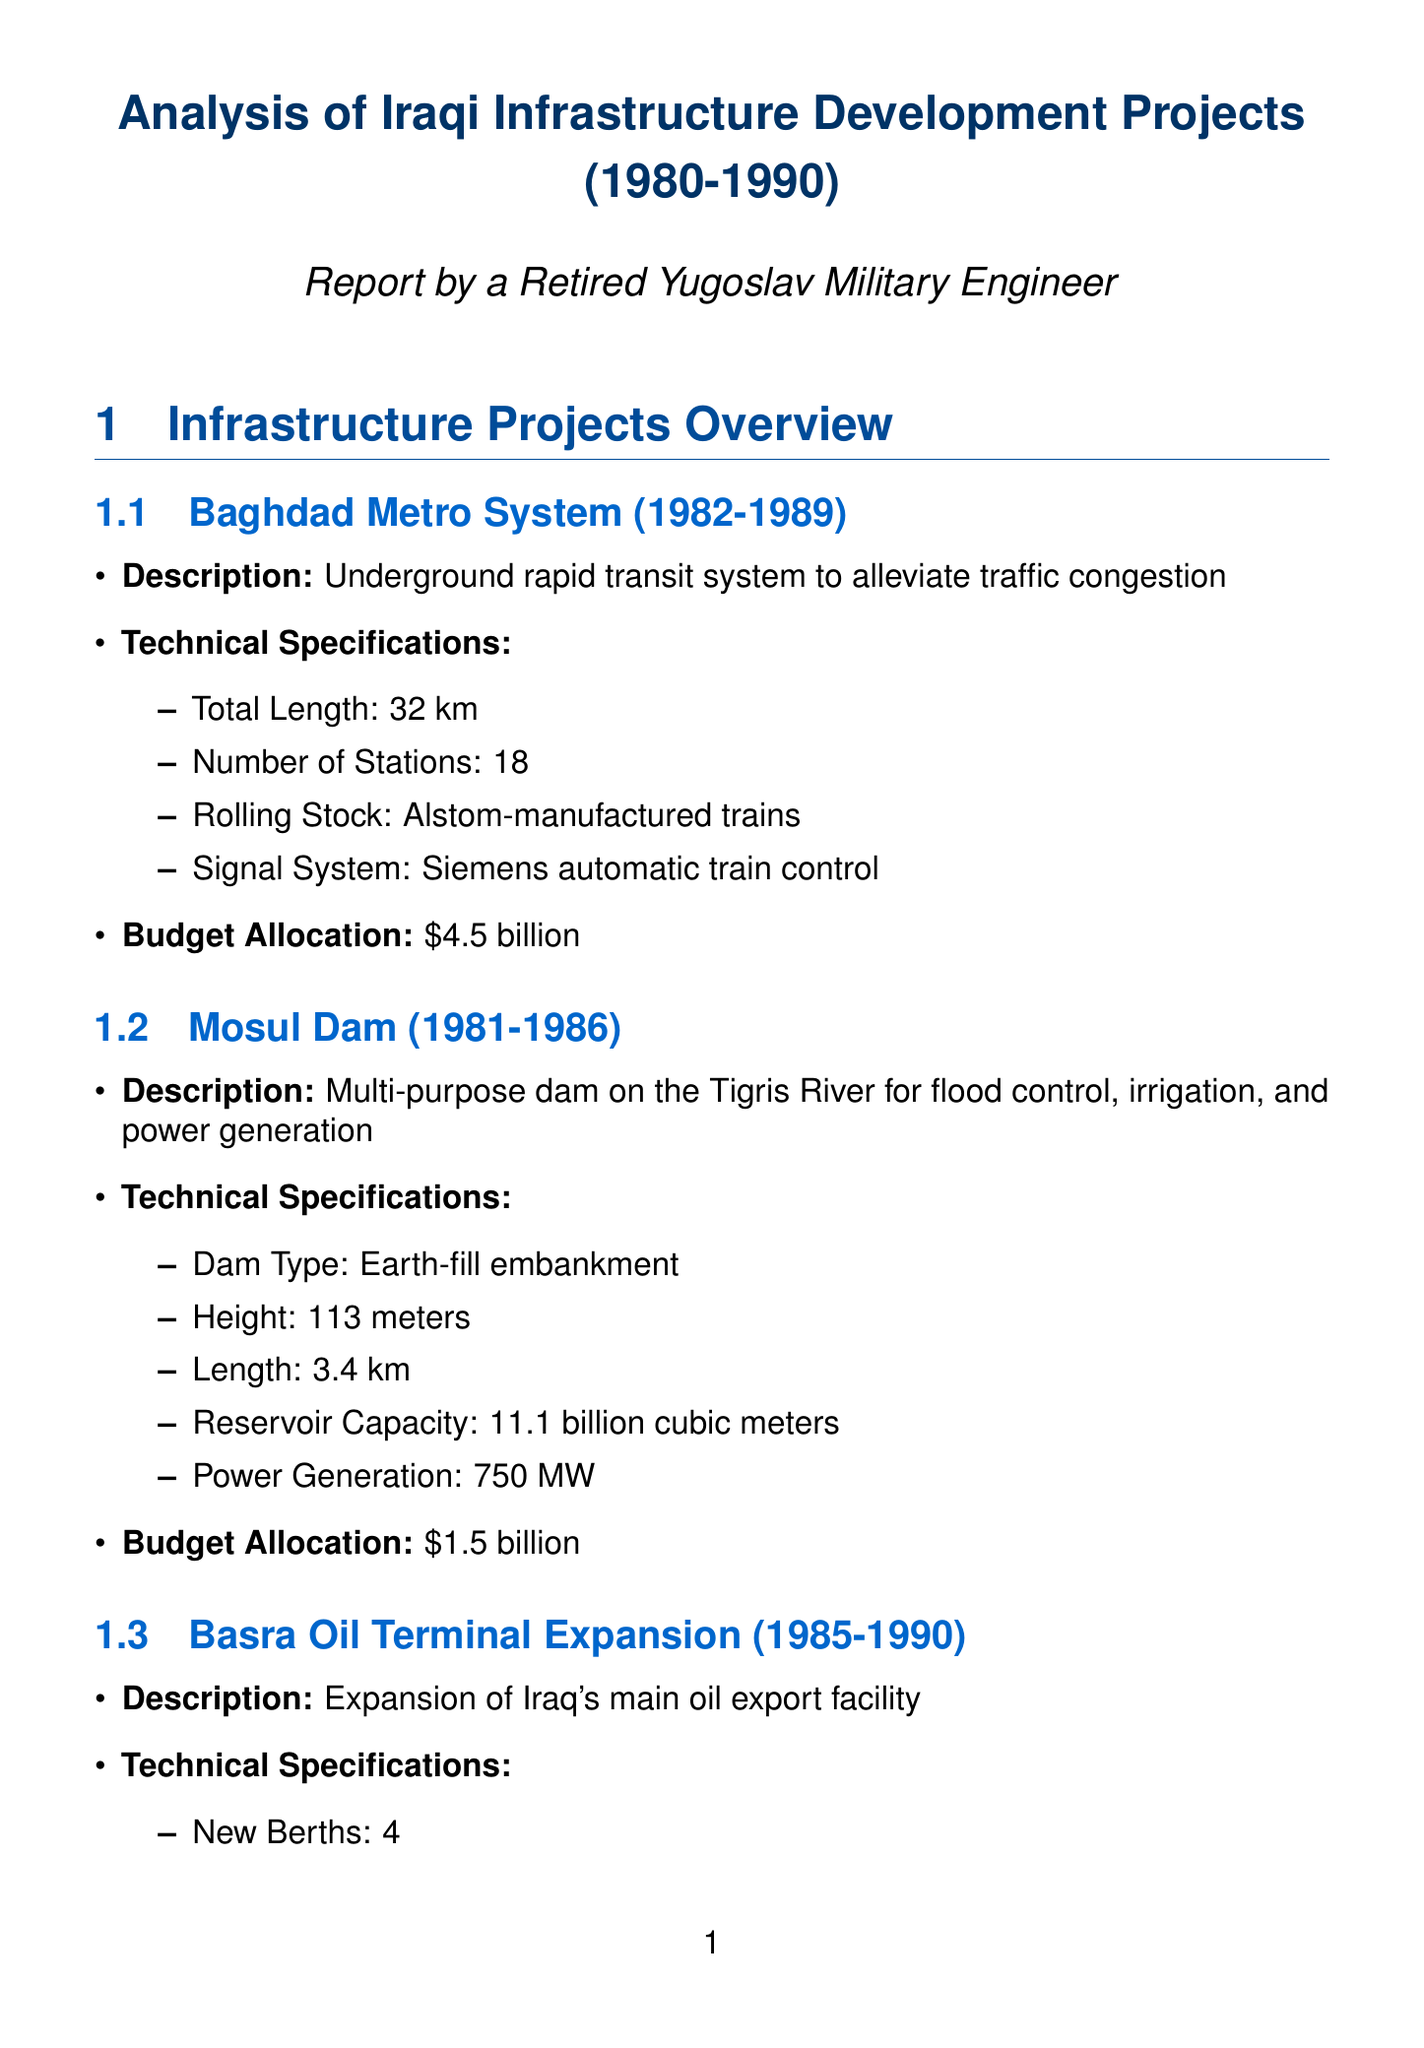What is the period of the Baghdad Metro System project? The period of the Baghdad Metro System is detailed in the project overview section, indicating it spanned from 1982 to 1989.
Answer: 1982-1989 What is the budget allocation for the Mosul Dam? The document specifies the budget allocation listed for the Mosul Dam project as $1.5 billion.
Answer: $1.5 billion What is the height of the Mosul Dam? The height of the Mosul Dam is specified in its technical specifications as 113 meters.
Answer: 113 meters Who was involved in the Baghdad Metro System project? The document names the key player involved in the Baghdad Metro System as Energoprojekt from Yugoslavia.
Answer: Energoprojekt What impact did the Iran-Iraq War have on projects? The document indicates that the Iran-Iraq War caused delayed timelines and increased risks for foreign contractors, thus impacting project execution.
Answer: Delayed project timelines What was Iraq's GDP growth average from 1980 to 1985? The GDP growth average over the specified period is presented in the economic impact section as 7.5% annually.
Answer: 7.5% What type of dam is the Mosul Dam? The document identifies the dam type in its specifications as an earth-fill embankment.
Answer: Earth-fill embankment What is the capacity of the oil terminal's storage? The storage capacity of the Basra Oil Terminal is mentioned in its technical specifications as 6.5 million barrels.
Answer: 6.5 million barrels What issue arose due to economic sanctions? The document states that economic sanctions led to difficulties in procuring advanced technology and materials for infrastructure projects.
Answer: Difficulty in procuring advanced technology What technological advancement was made in water treatment? It is noted in the technological advancements section that reverse osmosis desalination plants were introduced in southern Iraq.
Answer: Reverse osmosis desalination plants 